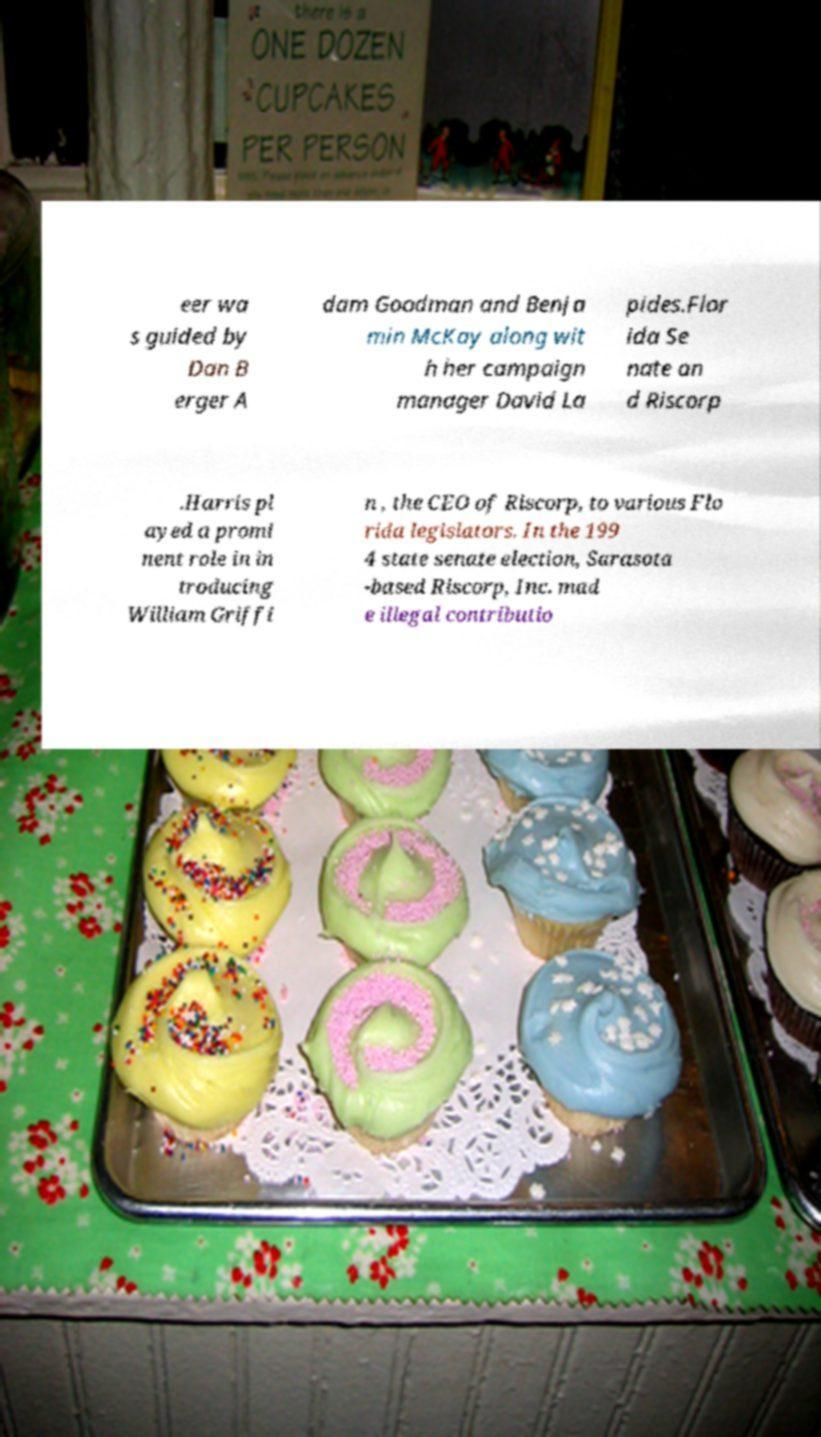For documentation purposes, I need the text within this image transcribed. Could you provide that? eer wa s guided by Dan B erger A dam Goodman and Benja min McKay along wit h her campaign manager David La pides.Flor ida Se nate an d Riscorp .Harris pl ayed a promi nent role in in troducing William Griffi n , the CEO of Riscorp, to various Flo rida legislators. In the 199 4 state senate election, Sarasota -based Riscorp, Inc. mad e illegal contributio 